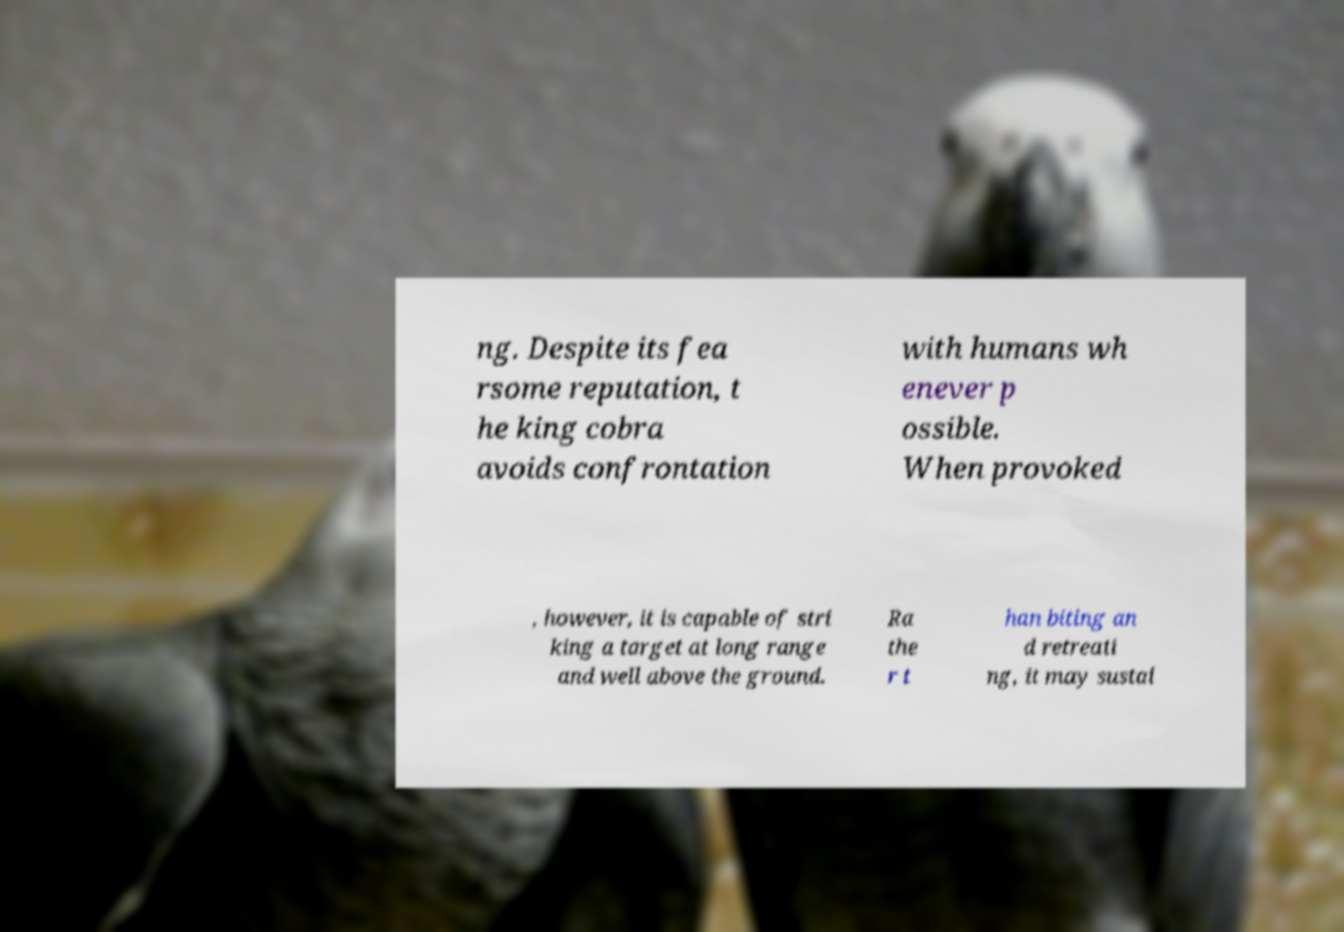Can you accurately transcribe the text from the provided image for me? ng. Despite its fea rsome reputation, t he king cobra avoids confrontation with humans wh enever p ossible. When provoked , however, it is capable of stri king a target at long range and well above the ground. Ra the r t han biting an d retreati ng, it may sustai 